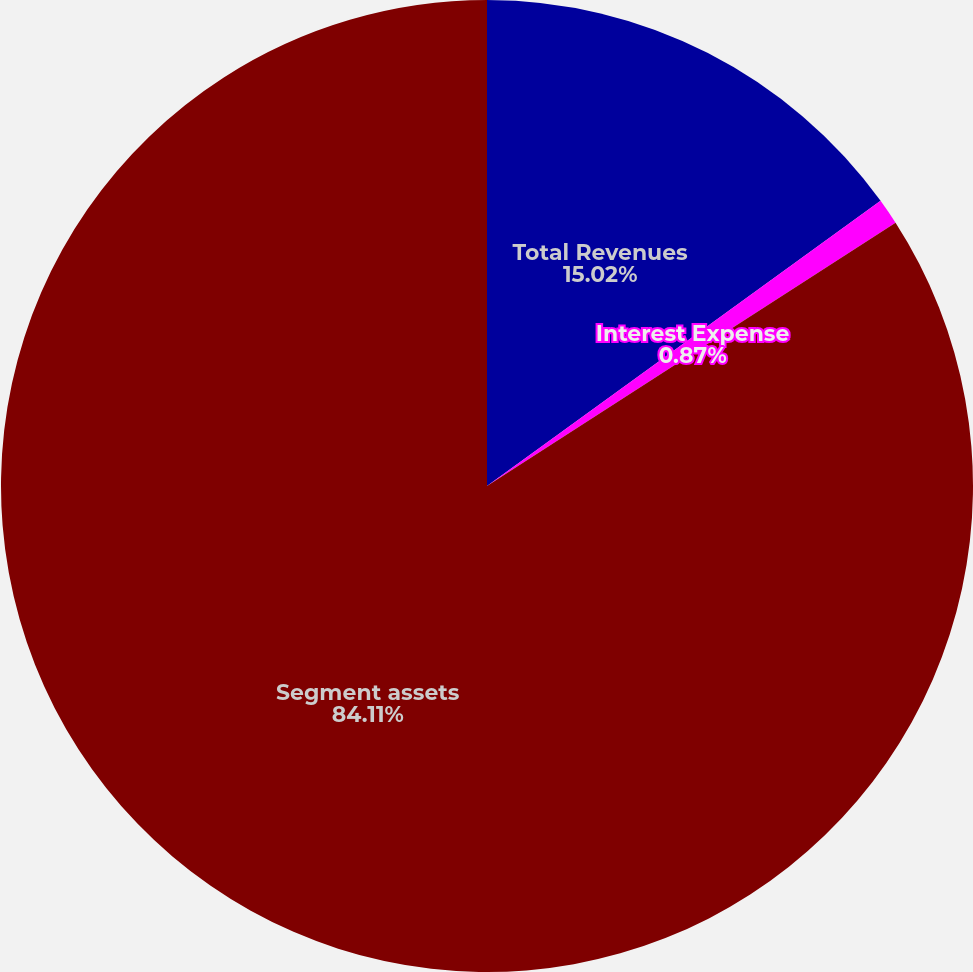Convert chart. <chart><loc_0><loc_0><loc_500><loc_500><pie_chart><fcel>Total Revenues<fcel>Interest Expense<fcel>Segment assets<nl><fcel>15.02%<fcel>0.87%<fcel>84.1%<nl></chart> 